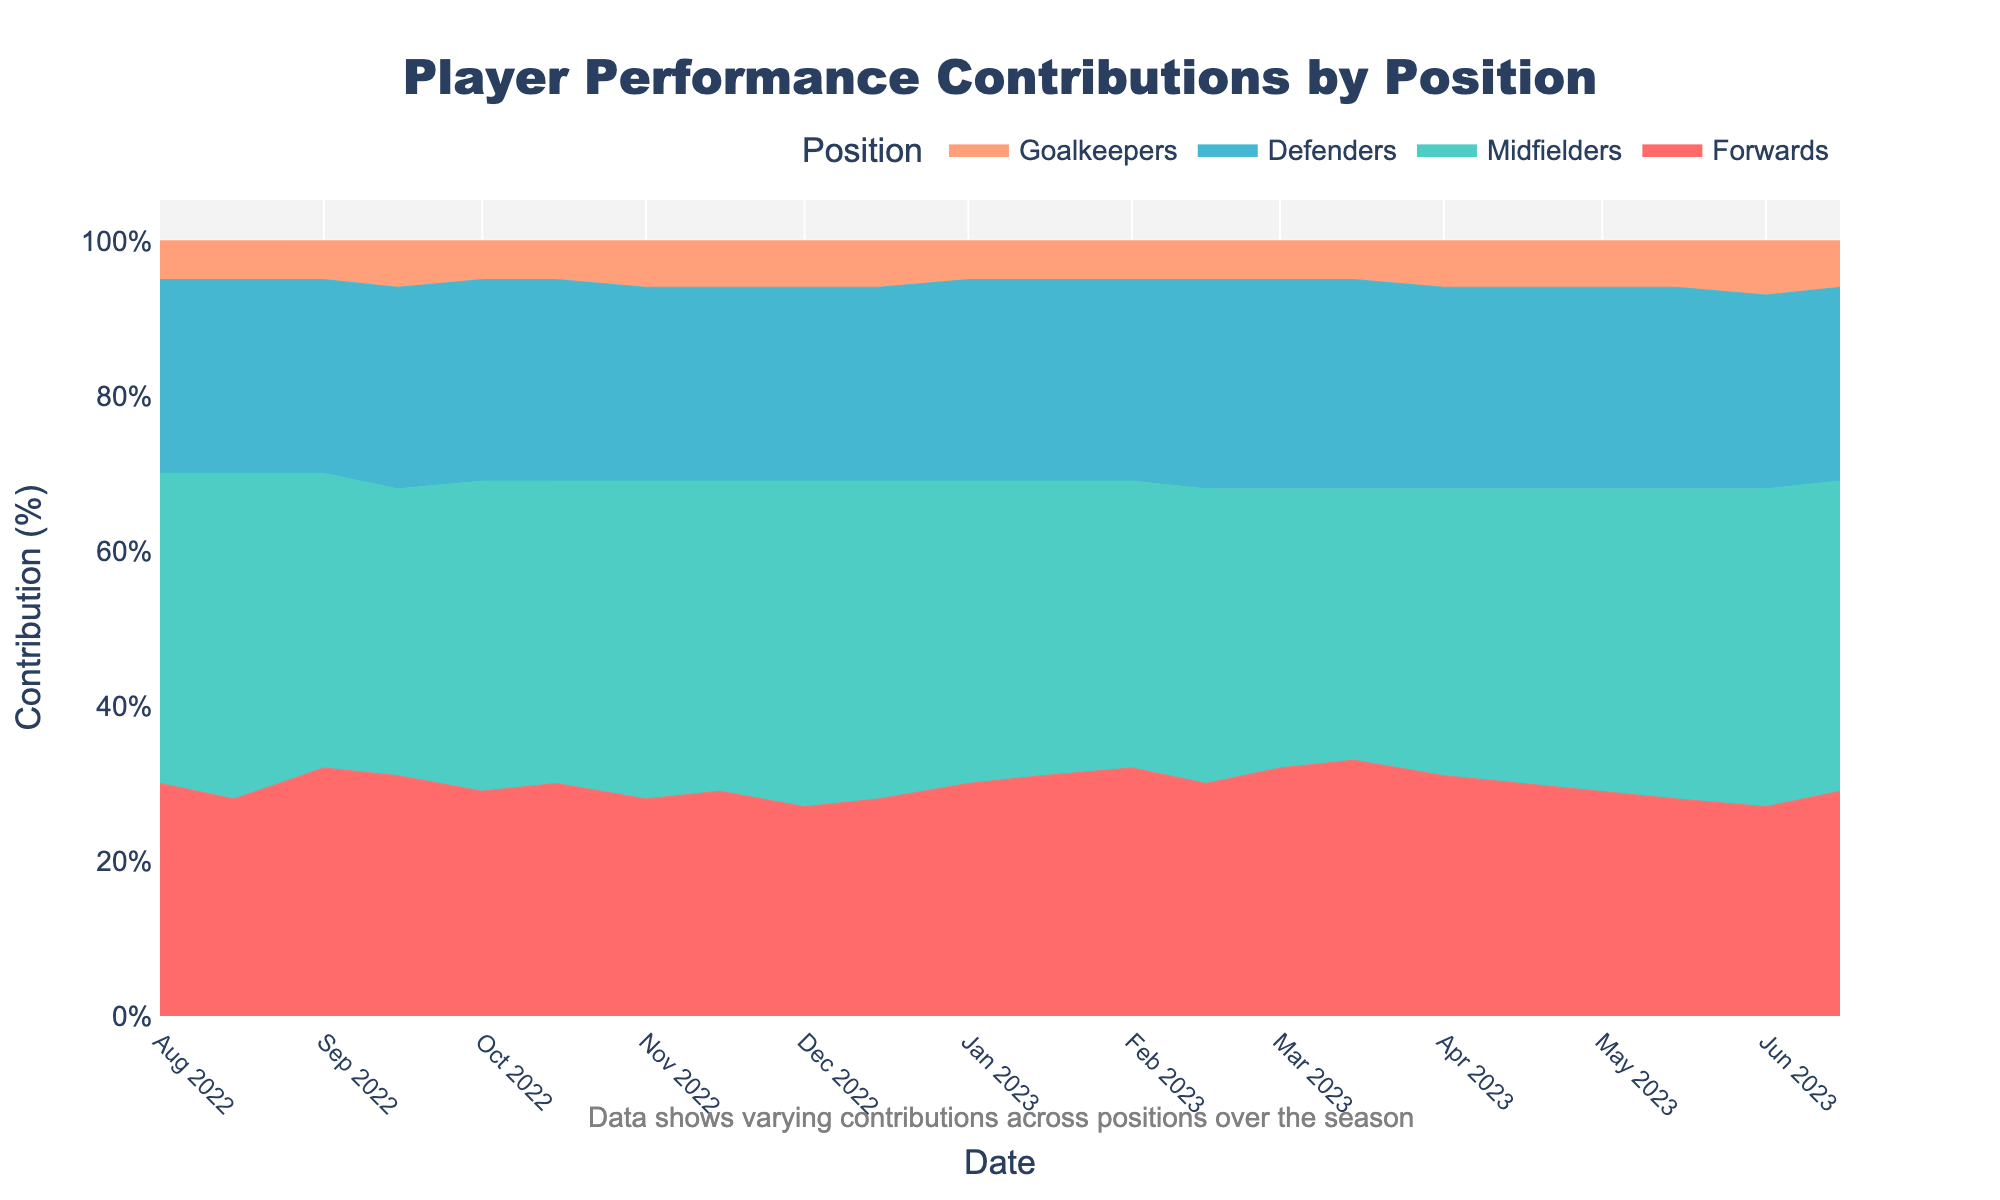What's the title of the chart? The title of the chart appears prominently above the visualization. The title describes what the chart is about.
Answer: Player Performance Contributions by Position What is the lowest percentage contribution made by the Goalkeepers, and when did it occur? The chart shows the contributions by position over time. By inspecting the Goalkeepers' (bottom color) segment, the lowest point is visually the smallest.
Answer: 5%, multiple instances Which position had the highest variance in contribution over the season? To identify the position with the highest variance, observe the fluctuation size in each segment's width over time. The most variable segment will appear to grow and shrink noticeably.
Answer: Midfielders What month saw the highest contribution from the Forwards? The Forwards' segment (top color) reaching its widest point indicates the highest contribution. By tracing this point vertically to the x-axis, determine the month.
Answer: Mar 2023 How did the contribution of Defenders change from August 2022 to June 2023? To assess the change, locate the Defenders' segment at both starting and ending points of the timeline, compare their widths, and observe the trend.
Answer: Increased slightly from 25% to 27% Which position had a constant percentage contribution throughout the season? A position with a constant contribution will have a segment width that does not significantly change over the timeline. Inspect each color band for significant uniformity.
Answer: None What is the average contribution percentage of Midfielders over the entire season? To find the average, observe the Midfielders' (second from the top) contribution at each time point, add them up, and divide by the number of points.
Answer: 39% During which period did the Goalkeepers' contribution increase the most? Identify where the Goalkeepers' segment (bottom) shows a noticeable increase in width compared to adjacent points, which marks the period of greatest rise.
Answer: Sep 2022 to Sep 2022 Which position had the most stable contribution throughout the season? The most stable position will have the least fluctuation in the width of its segment. Look for consistent thickness in a segment throughout the timeline.
Answer: Defenders What trend do you observe in the Midfielders' contributions from Feb 2023 to Mar 2023? Observe the segment for Midfielders (second from the top) between Feb and Mar 2023 for any noticeable increase or decrease.
Answer: Decrease 